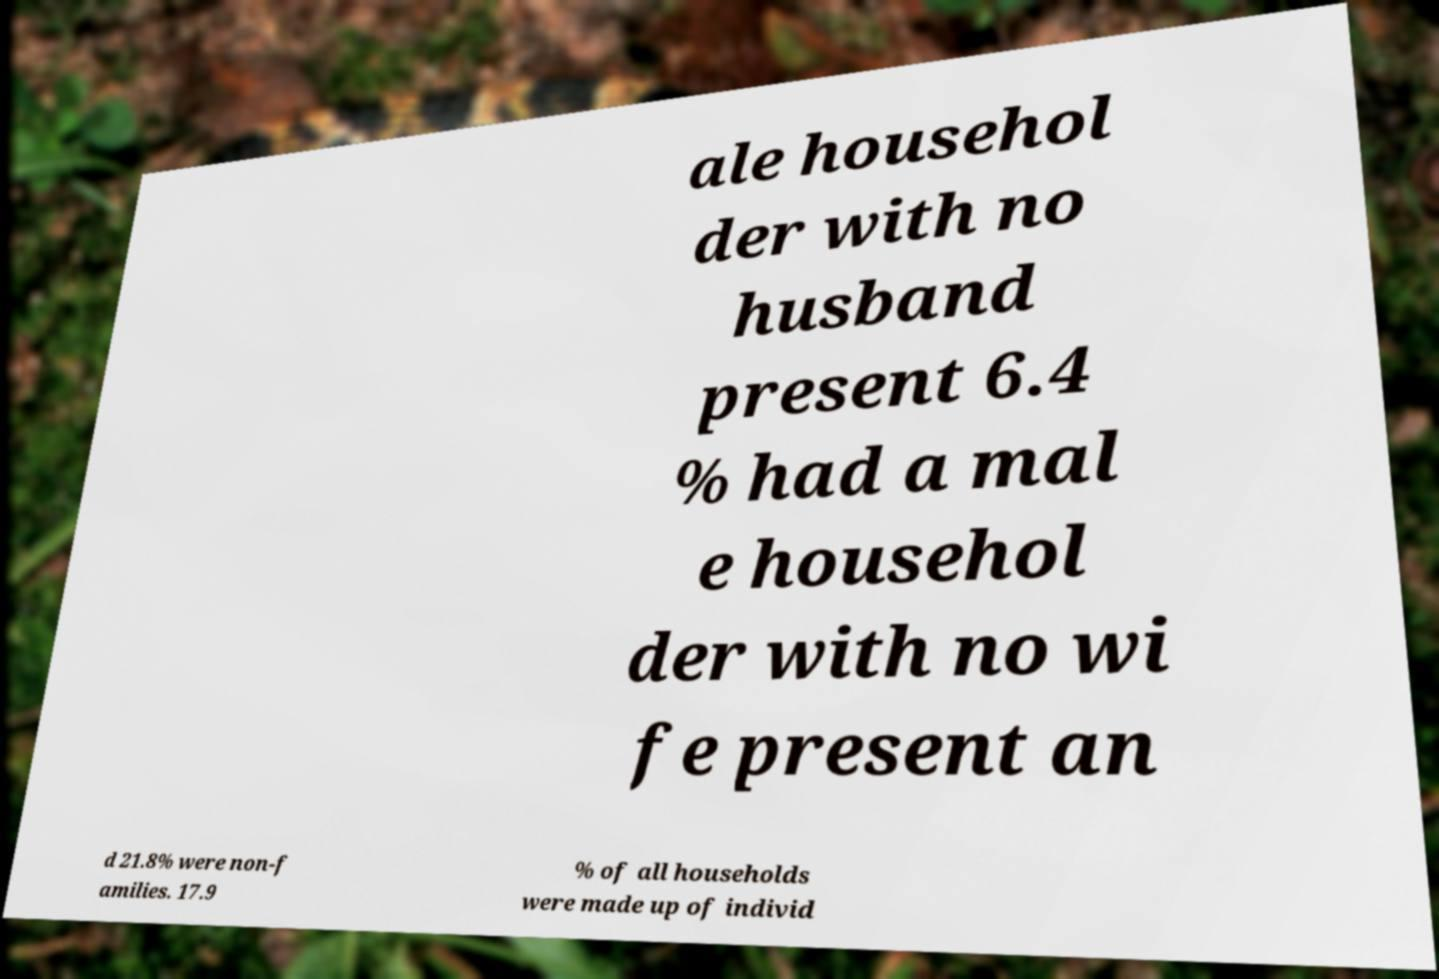Please read and relay the text visible in this image. What does it say? ale househol der with no husband present 6.4 % had a mal e househol der with no wi fe present an d 21.8% were non-f amilies. 17.9 % of all households were made up of individ 